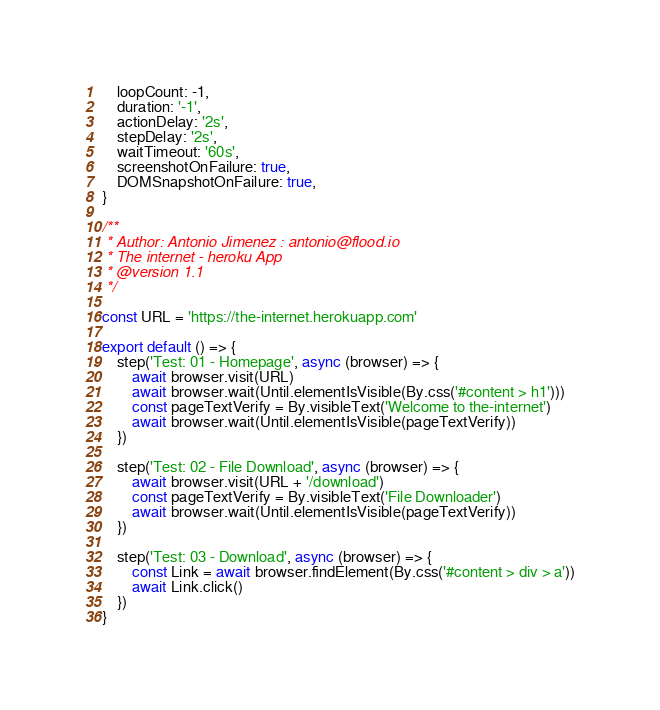<code> <loc_0><loc_0><loc_500><loc_500><_TypeScript_>	loopCount: -1,
	duration: '-1',
	actionDelay: '2s',
	stepDelay: '2s',
	waitTimeout: '60s',
	screenshotOnFailure: true,
	DOMSnapshotOnFailure: true,
}

/**
 * Author: Antonio Jimenez : antonio@flood.io
 * The internet - heroku App
 * @version 1.1
 */

const URL = 'https://the-internet.herokuapp.com'

export default () => {
	step('Test: 01 - Homepage', async (browser) => {
		await browser.visit(URL)
		await browser.wait(Until.elementIsVisible(By.css('#content > h1')))
		const pageTextVerify = By.visibleText('Welcome to the-internet')
		await browser.wait(Until.elementIsVisible(pageTextVerify))
	})

	step('Test: 02 - File Download', async (browser) => {
		await browser.visit(URL + '/download')
		const pageTextVerify = By.visibleText('File Downloader')
		await browser.wait(Until.elementIsVisible(pageTextVerify))
	})

	step('Test: 03 - Download', async (browser) => {
		const Link = await browser.findElement(By.css('#content > div > a'))
		await Link.click()
	})
}
</code> 